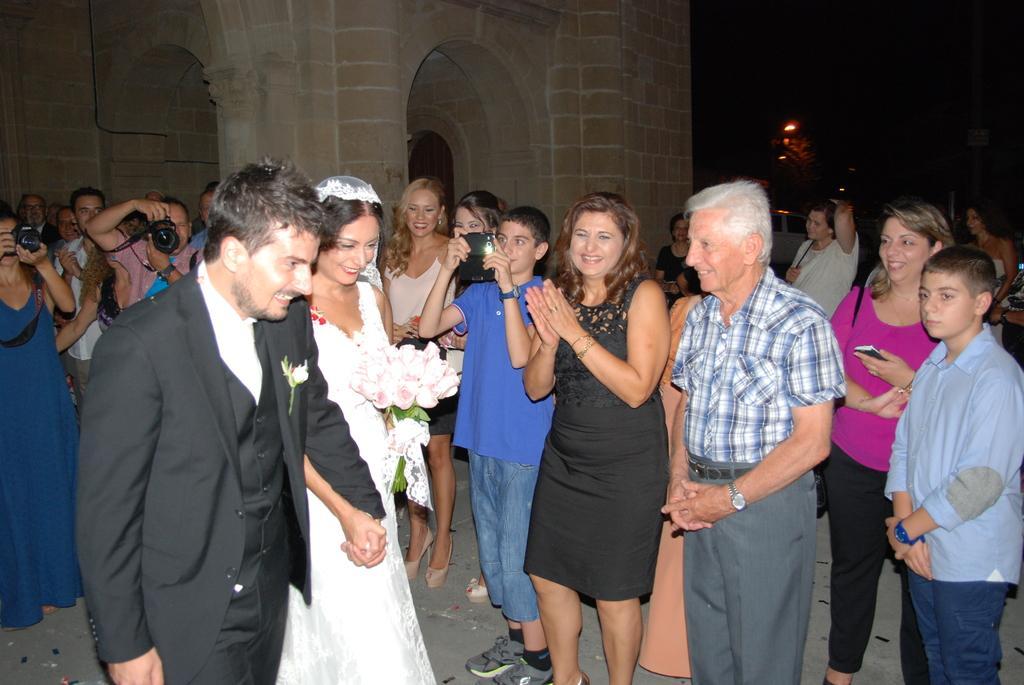Can you describe this image briefly? In the center of the image, we can see a bride and a bridegroom and one of them is holding a bouquet and in the background, there are people and some of them are holding cameras and mobiles in their hands and there is a wall and we can see a some lights. At the bottom, there is a floor. 